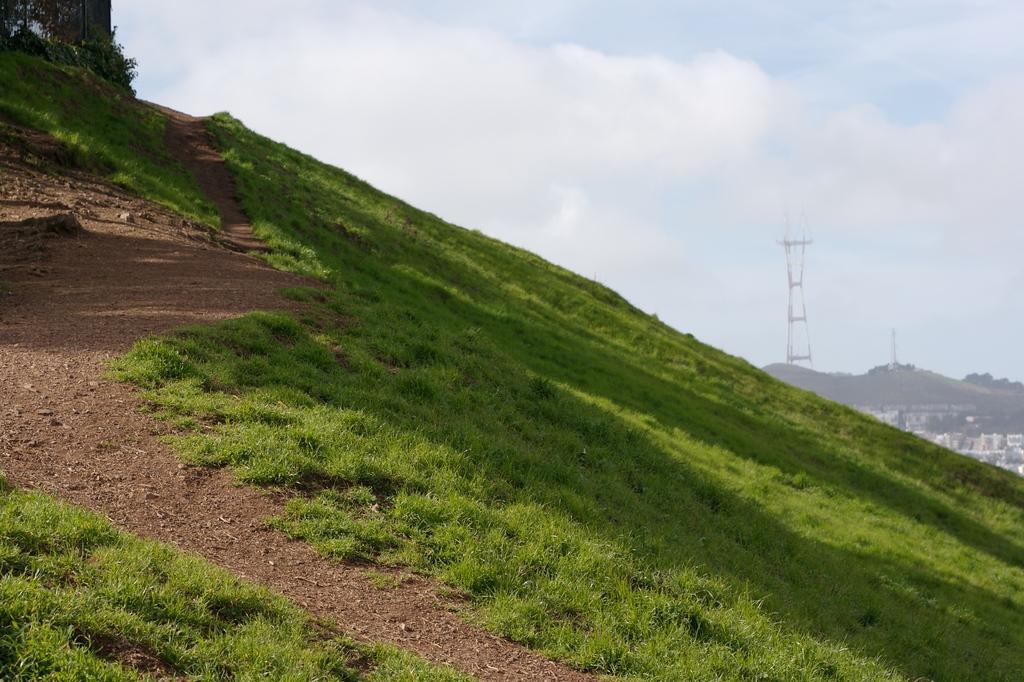Describe this image in one or two sentences. In this picture, there is a hill towards the right. On the hill there is grass and a lane. Towards the right there are hills, buildings and a tower. On the top there is a sky with clouds. 